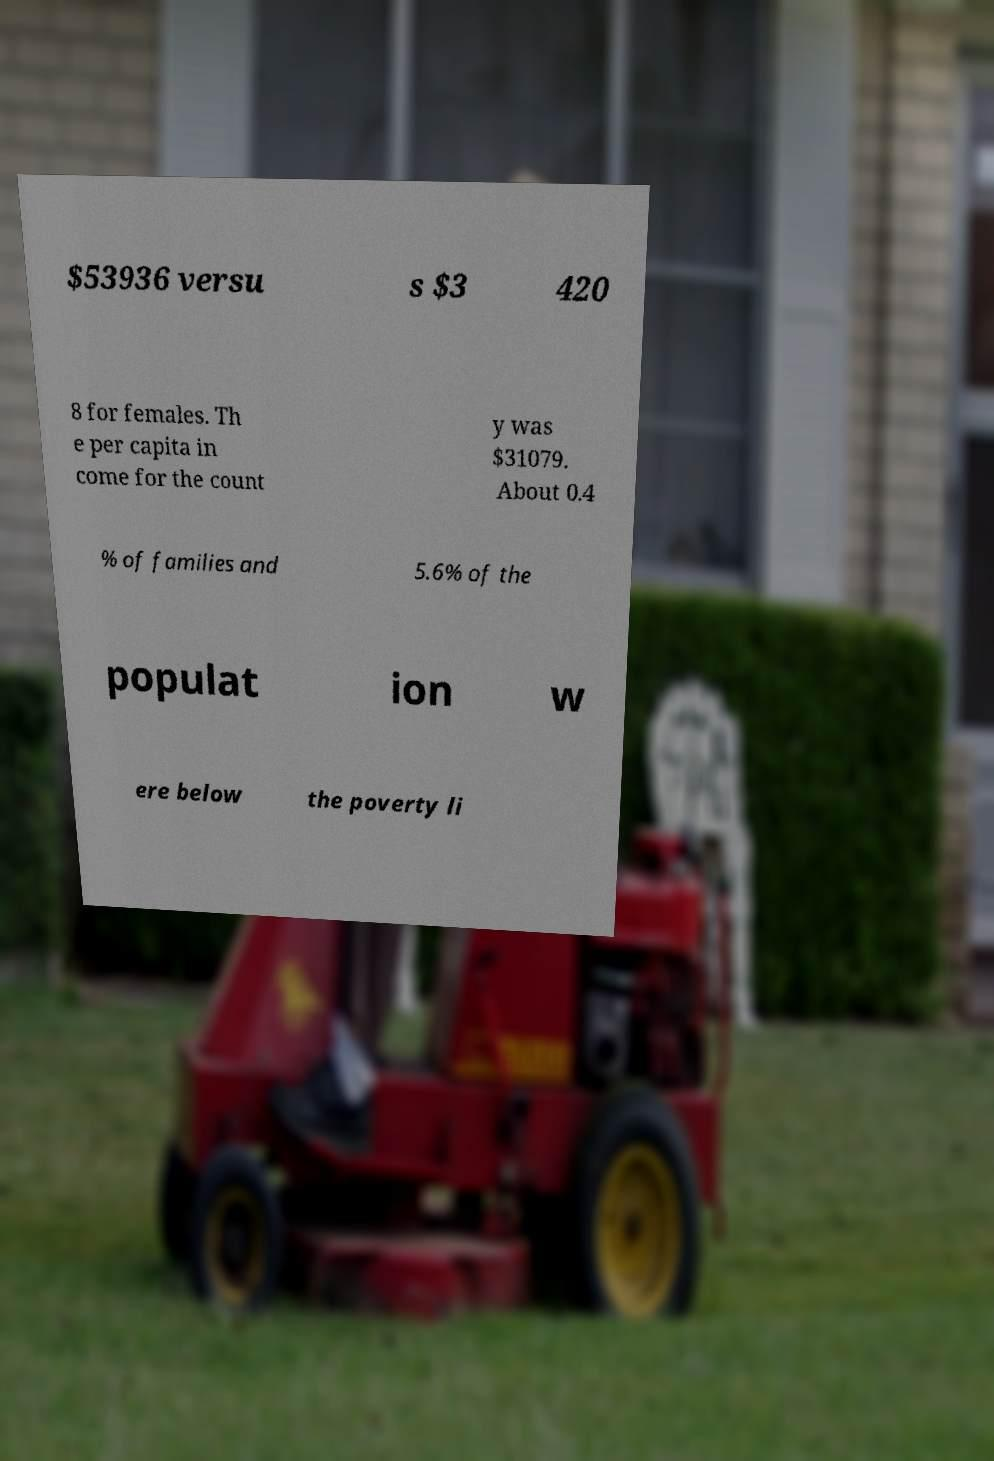For documentation purposes, I need the text within this image transcribed. Could you provide that? $53936 versu s $3 420 8 for females. Th e per capita in come for the count y was $31079. About 0.4 % of families and 5.6% of the populat ion w ere below the poverty li 